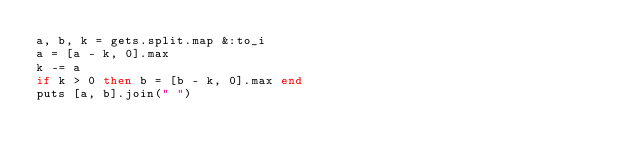<code> <loc_0><loc_0><loc_500><loc_500><_Ruby_>a, b, k = gets.split.map &:to_i
a = [a - k, 0].max
k -= a
if k > 0 then b = [b - k, 0].max end
puts [a, b].join(" ")
</code> 